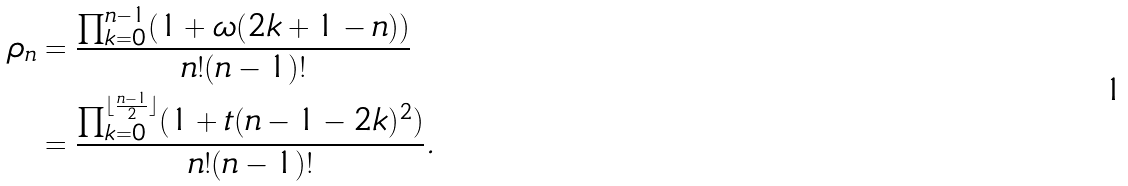Convert formula to latex. <formula><loc_0><loc_0><loc_500><loc_500>\rho _ { n } & = \frac { \prod _ { k = 0 } ^ { n - 1 } ( 1 + \omega ( 2 k + 1 - n ) ) } { n ! ( n - 1 ) ! } \\ & = \frac { \prod _ { k = 0 } ^ { \lfloor \frac { n - 1 } 2 \rfloor } ( 1 + t ( n - 1 - 2 k ) ^ { 2 } ) } { n ! ( n - 1 ) ! } .</formula> 